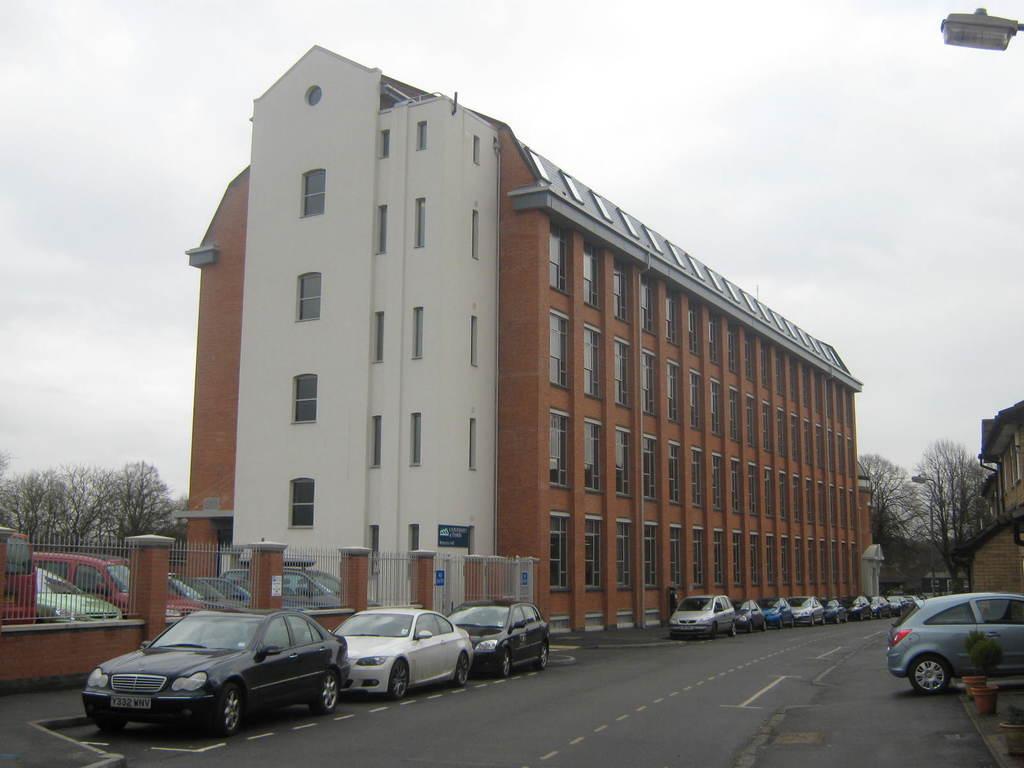Describe this image in one or two sentences. This picture shows buildings and we see trees and few cars parked on the side of the road and we see a blue cloudy sky and a pole light and plants in the pots. 